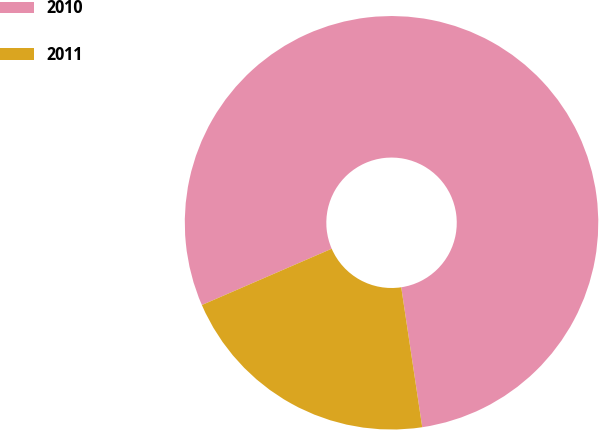Convert chart to OTSL. <chart><loc_0><loc_0><loc_500><loc_500><pie_chart><fcel>2010<fcel>2011<nl><fcel>79.14%<fcel>20.86%<nl></chart> 